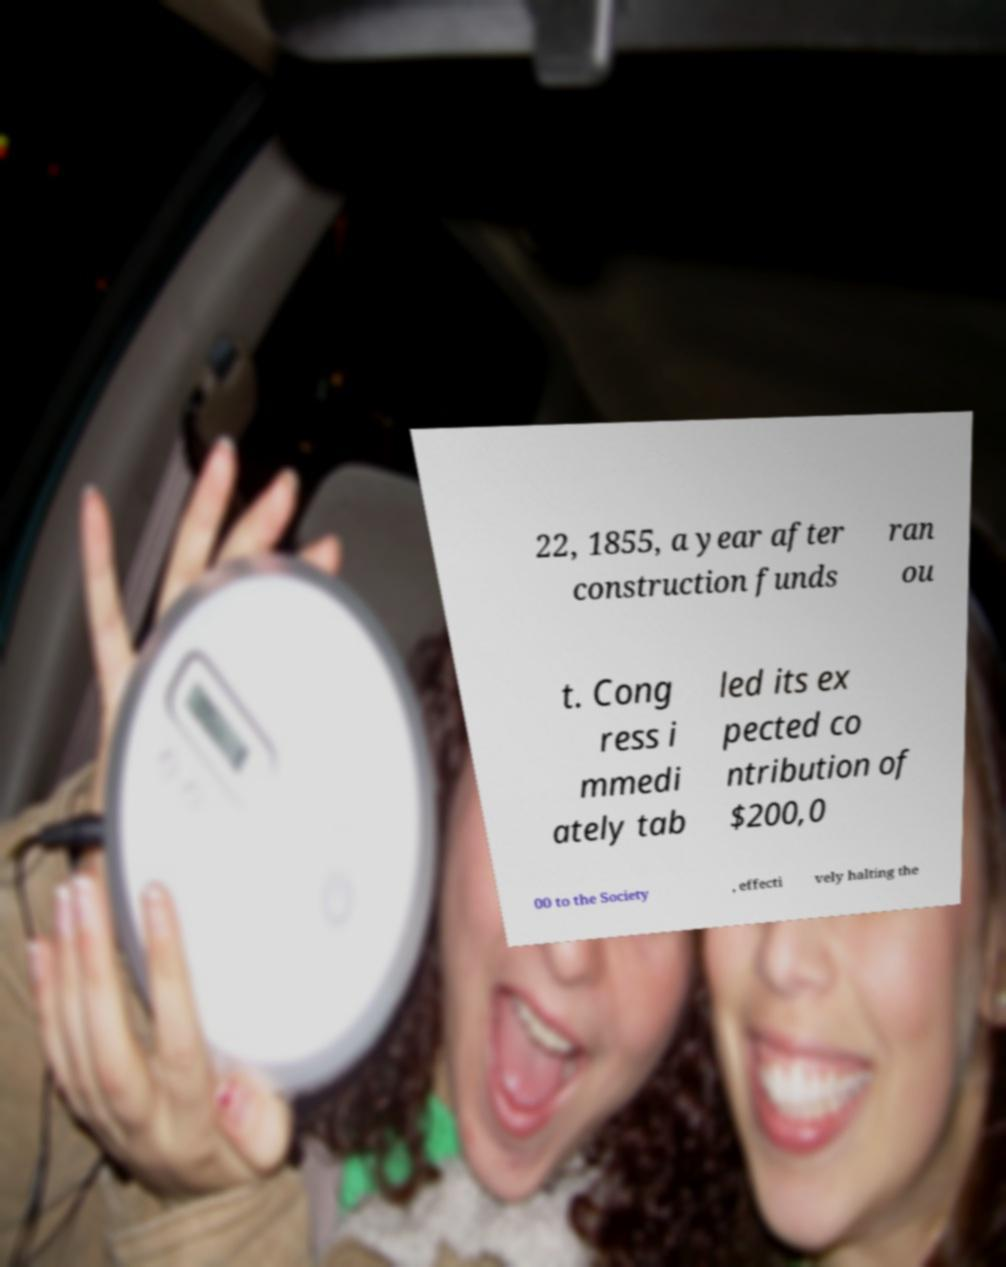Can you accurately transcribe the text from the provided image for me? 22, 1855, a year after construction funds ran ou t. Cong ress i mmedi ately tab led its ex pected co ntribution of $200,0 00 to the Society , effecti vely halting the 